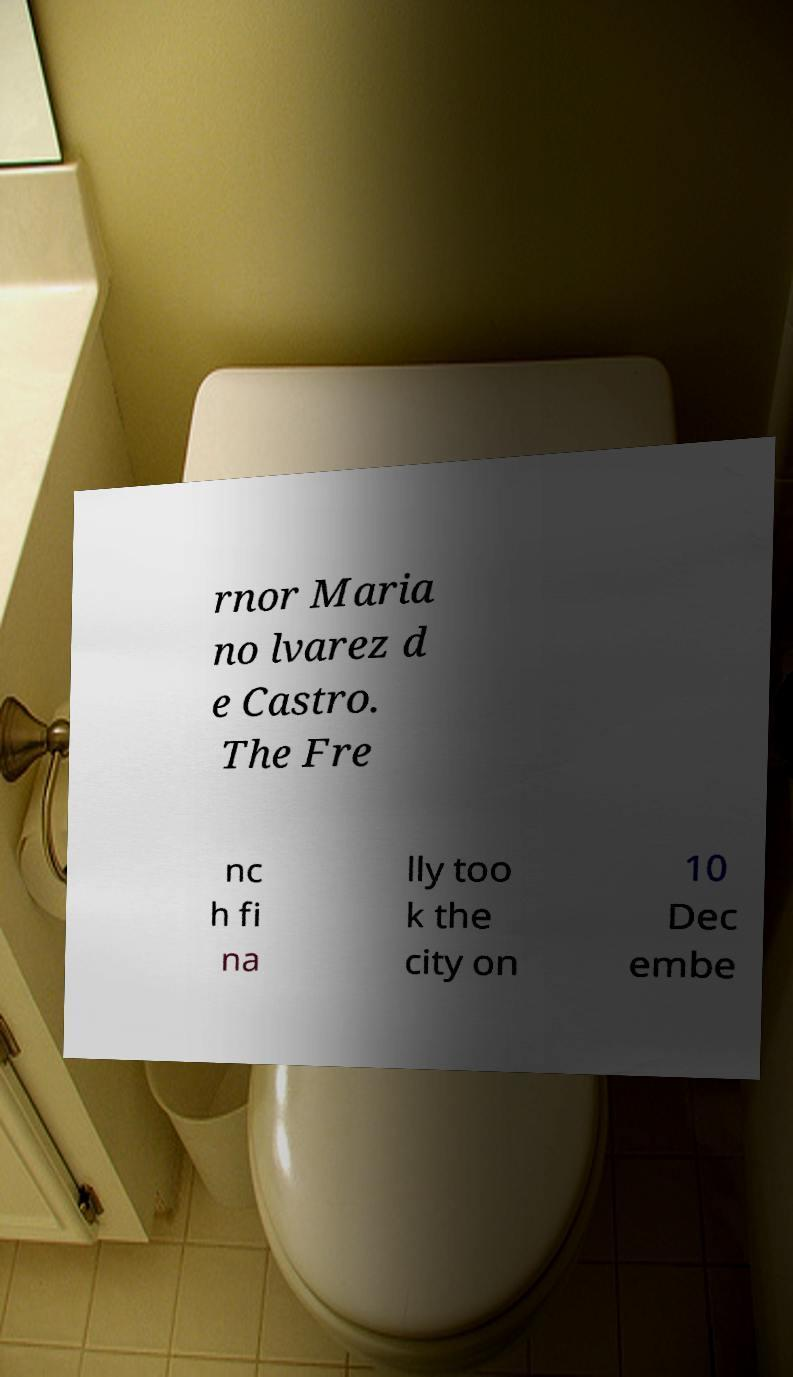For documentation purposes, I need the text within this image transcribed. Could you provide that? rnor Maria no lvarez d e Castro. The Fre nc h fi na lly too k the city on 10 Dec embe 